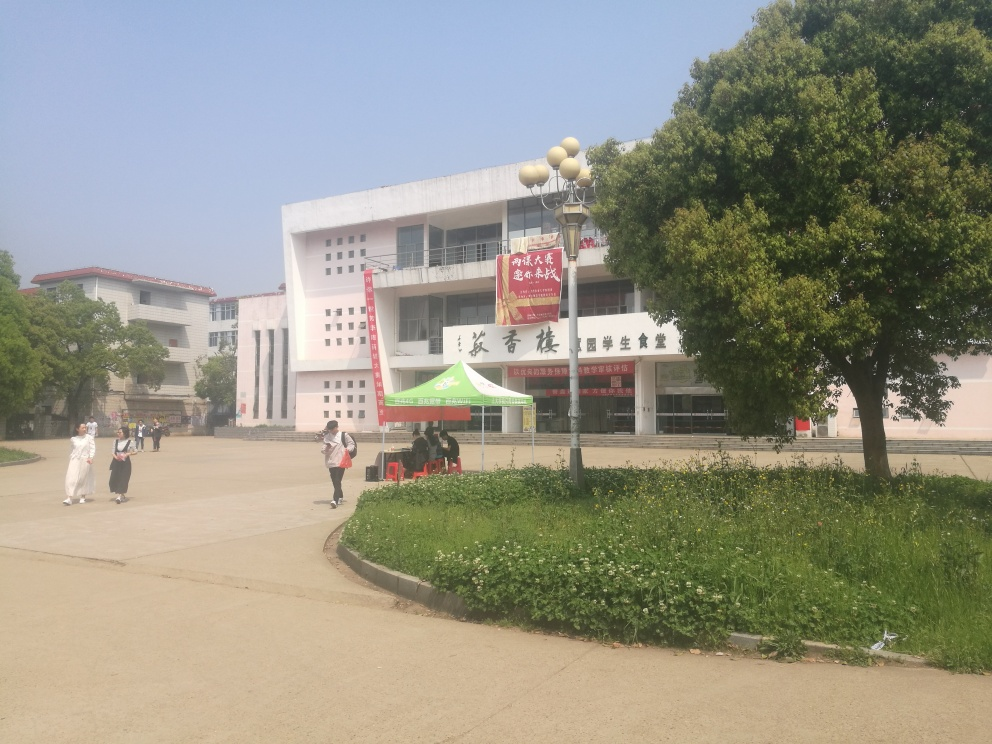Can you describe the architectural style of the building in the background? The architecture of the building is modern with minimalistic design elements. It features clean lines and a pale color palette, mostly free from ornamentation, which is indicative of contemporary construction trends aiming for functionality and simplicity. 